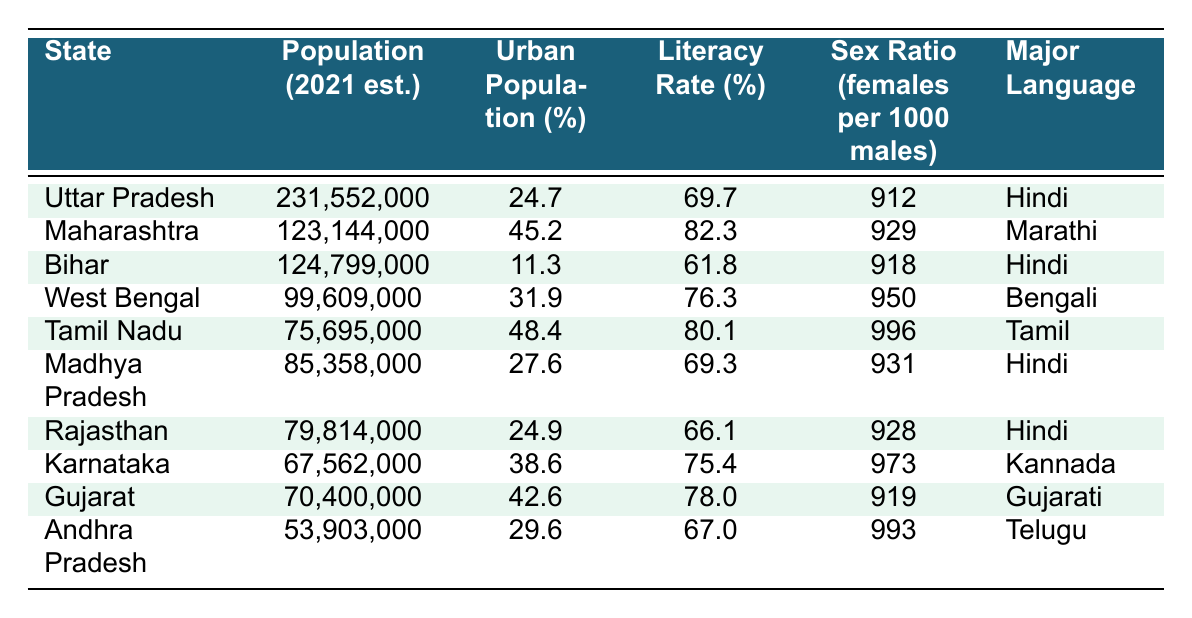What is the population of Maharashtra? The population of Maharashtra is listed in the table under the "Population (2021 est.)" column for that state. It shows 123,144,000.
Answer: 123,144,000 Which state has the highest literacy rate? The literacy rates for each state are provided in the table. Scanning through the values, Tamil Nadu has the highest literacy rate at 80.1%.
Answer: Tamil Nadu Is the urban population percentage in Bihar less than 20%? The table indicates the urban population percentage for Bihar as 11.3%. Since 11.3% is indeed less than 20%, the statement is true.
Answer: Yes What is the average sex ratio for states with Hindi as the major language? The states with Hindi as the major language are Uttar Pradesh, Bihar, Madhya Pradesh, and Rajasthan. Their sex ratios are 912, 918, 931, and 928, respectively. Adding these gives 912 + 918 + 931 + 928 = 3689. Dividing by 4 gives the average: 3689 / 4 = 922.25, which we can round to 922 when focusing on whole numbers.
Answer: 922 Which state has the lowest urban population percentage and what is that percentage? From the urban population percentages given in the table, Bihar has the lowest percentage at 11.3%.
Answer: 11.3% 